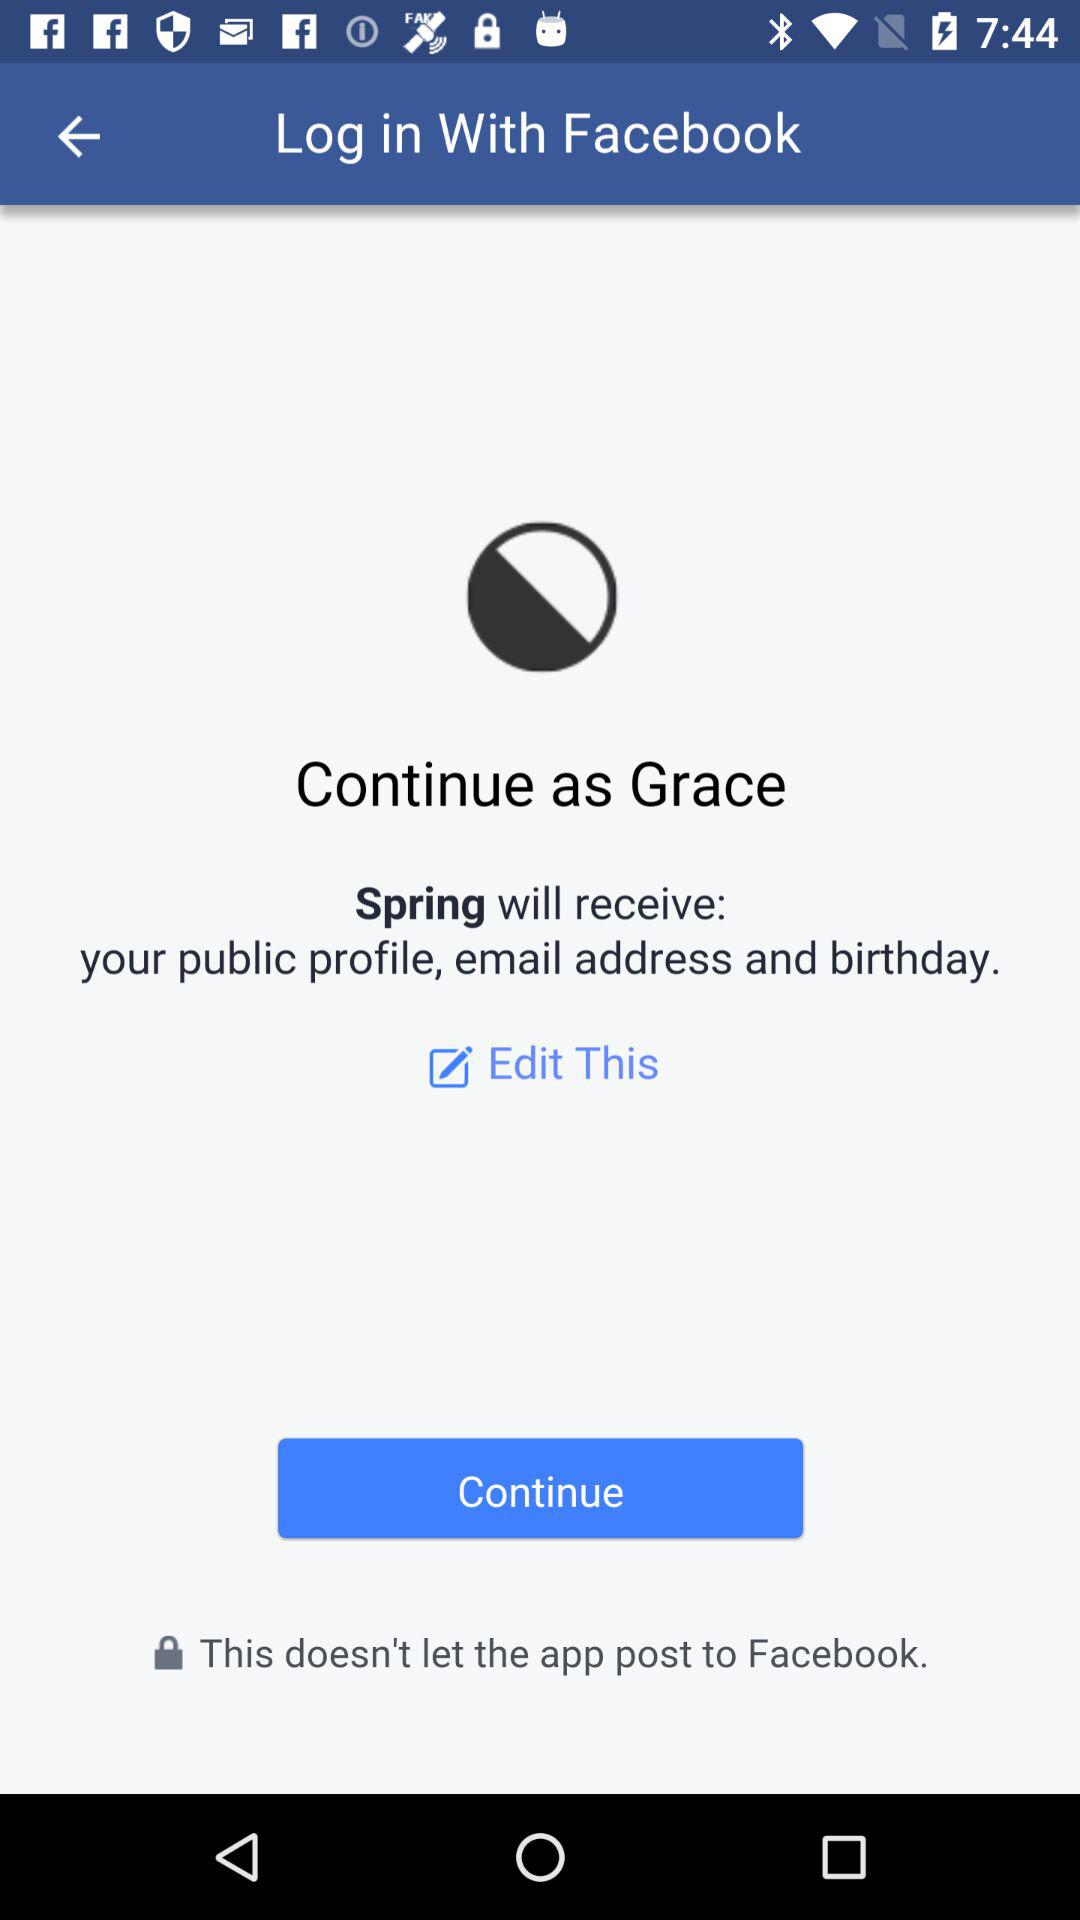What is the user name? The user name is Grace. 